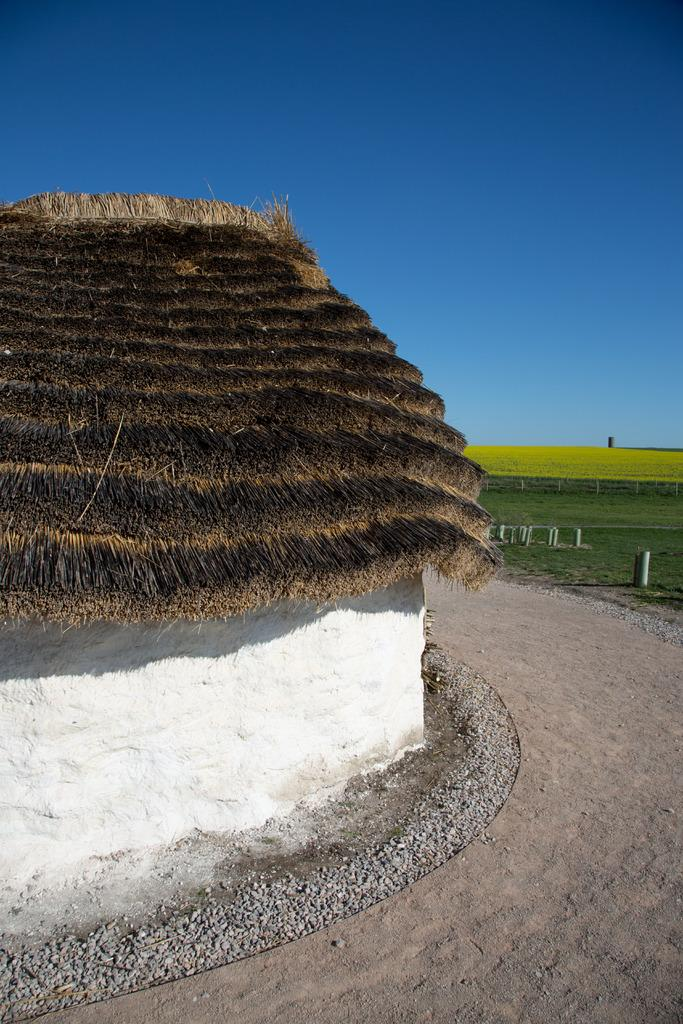What type of surface is on the wall in the image? There is a wall with grass in the image. What can be seen on the ground in the image? There is ground visible in the image. What objects are present in the image that resemble long, thin poles? There are rods in the image. What type of vegetation is present in the image? Grass is present in the image. What part of the natural environment is visible in the image? The sky is visible in the image. What type of circle can be seen in the image? There is no circle present in the image. What knowledge can be gained from the image? The image provides visual information about the wall, ground, rods, grass, and sky, but it does not convey any specific knowledge or teach any lessons. 